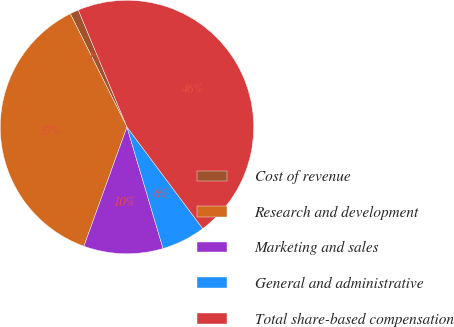Convert chart. <chart><loc_0><loc_0><loc_500><loc_500><pie_chart><fcel>Cost of revenue<fcel>Research and development<fcel>Marketing and sales<fcel>General and administrative<fcel>Total share-based compensation<nl><fcel>1.11%<fcel>37.1%<fcel>10.11%<fcel>5.61%<fcel>46.07%<nl></chart> 